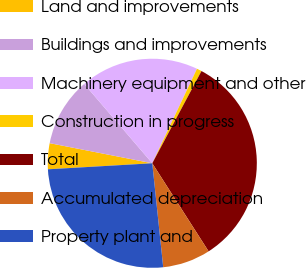<chart> <loc_0><loc_0><loc_500><loc_500><pie_chart><fcel>Land and improvements<fcel>Buildings and improvements<fcel>Machinery equipment and other<fcel>Construction in progress<fcel>Total<fcel>Accumulated depreciation<fcel>Property plant and<nl><fcel>4.0%<fcel>10.63%<fcel>18.32%<fcel>0.77%<fcel>33.14%<fcel>7.39%<fcel>25.75%<nl></chart> 